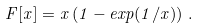Convert formula to latex. <formula><loc_0><loc_0><loc_500><loc_500>F [ x ] = x \left ( 1 - e x p ( 1 / x ) \right ) \, .</formula> 